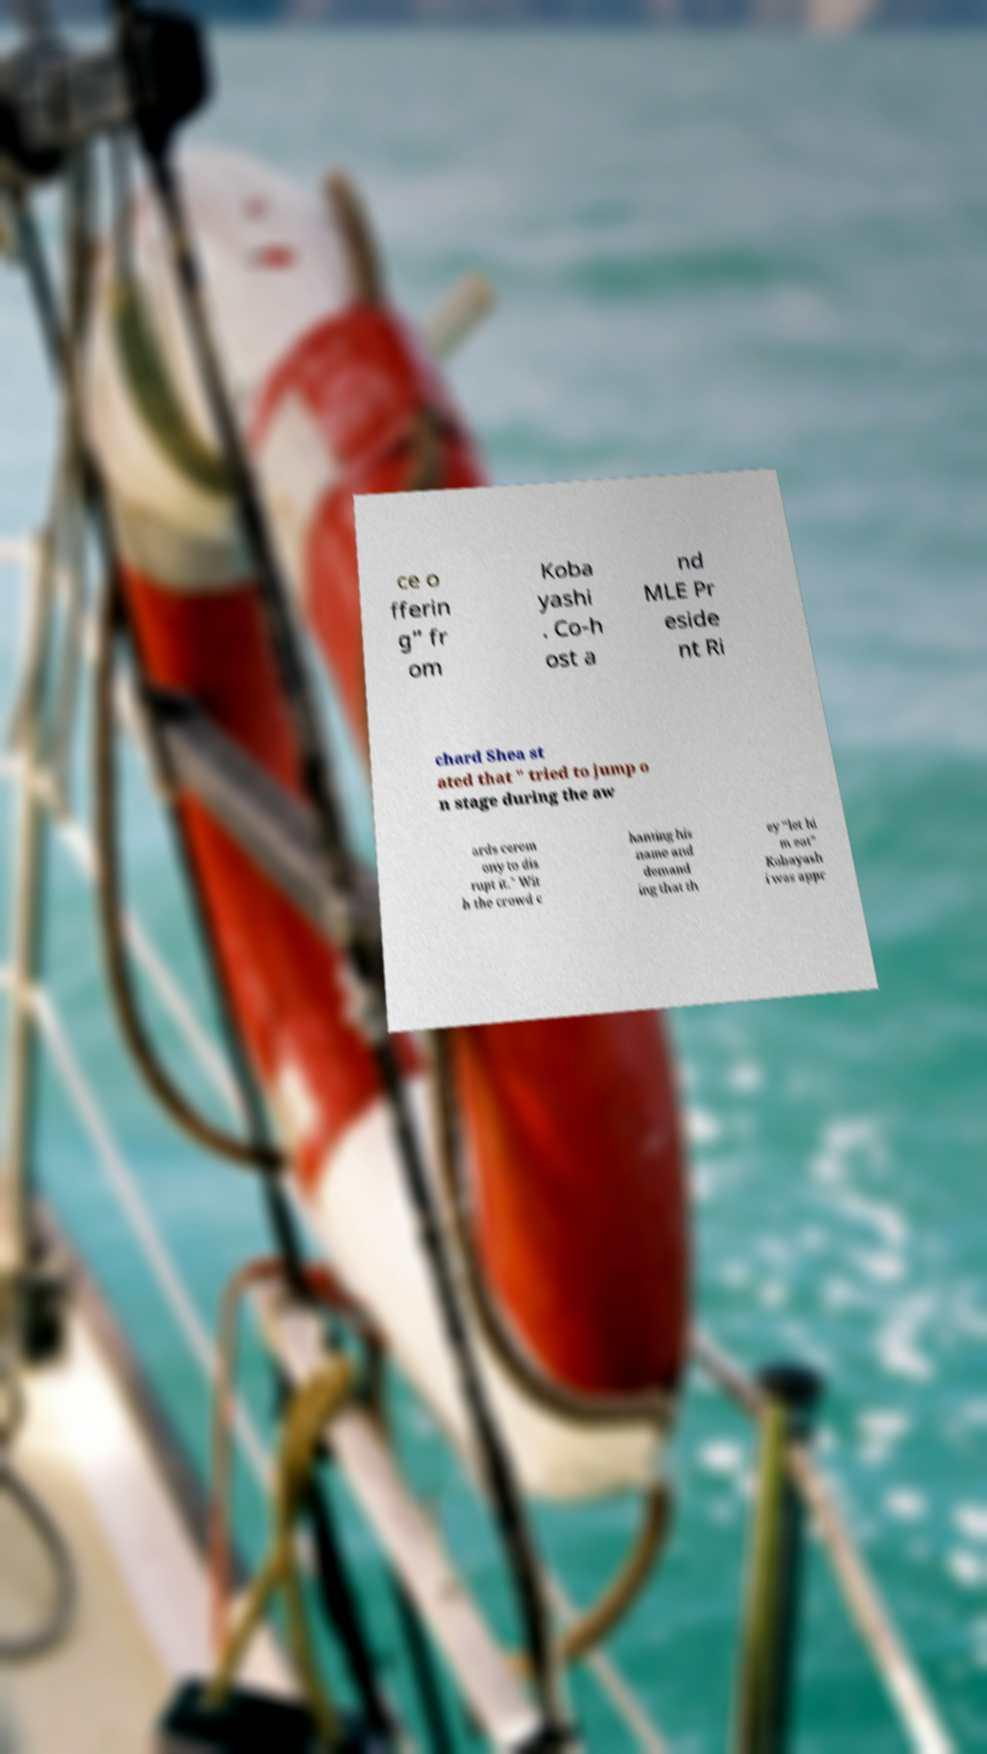Please identify and transcribe the text found in this image. ce o fferin g” fr om Koba yashi . Co-h ost a nd MLE Pr eside nt Ri chard Shea st ated that " tried to jump o n stage during the aw ards cerem ony to dis rupt it." Wit h the crowd c hanting his name and demand ing that th ey “let hi m eat” Kobayash i was appr 